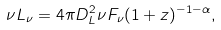<formula> <loc_0><loc_0><loc_500><loc_500>\nu L _ { \nu } = 4 \pi D _ { L } ^ { 2 } \nu F _ { \nu } ( 1 + z ) ^ { - 1 - \alpha } ,</formula> 